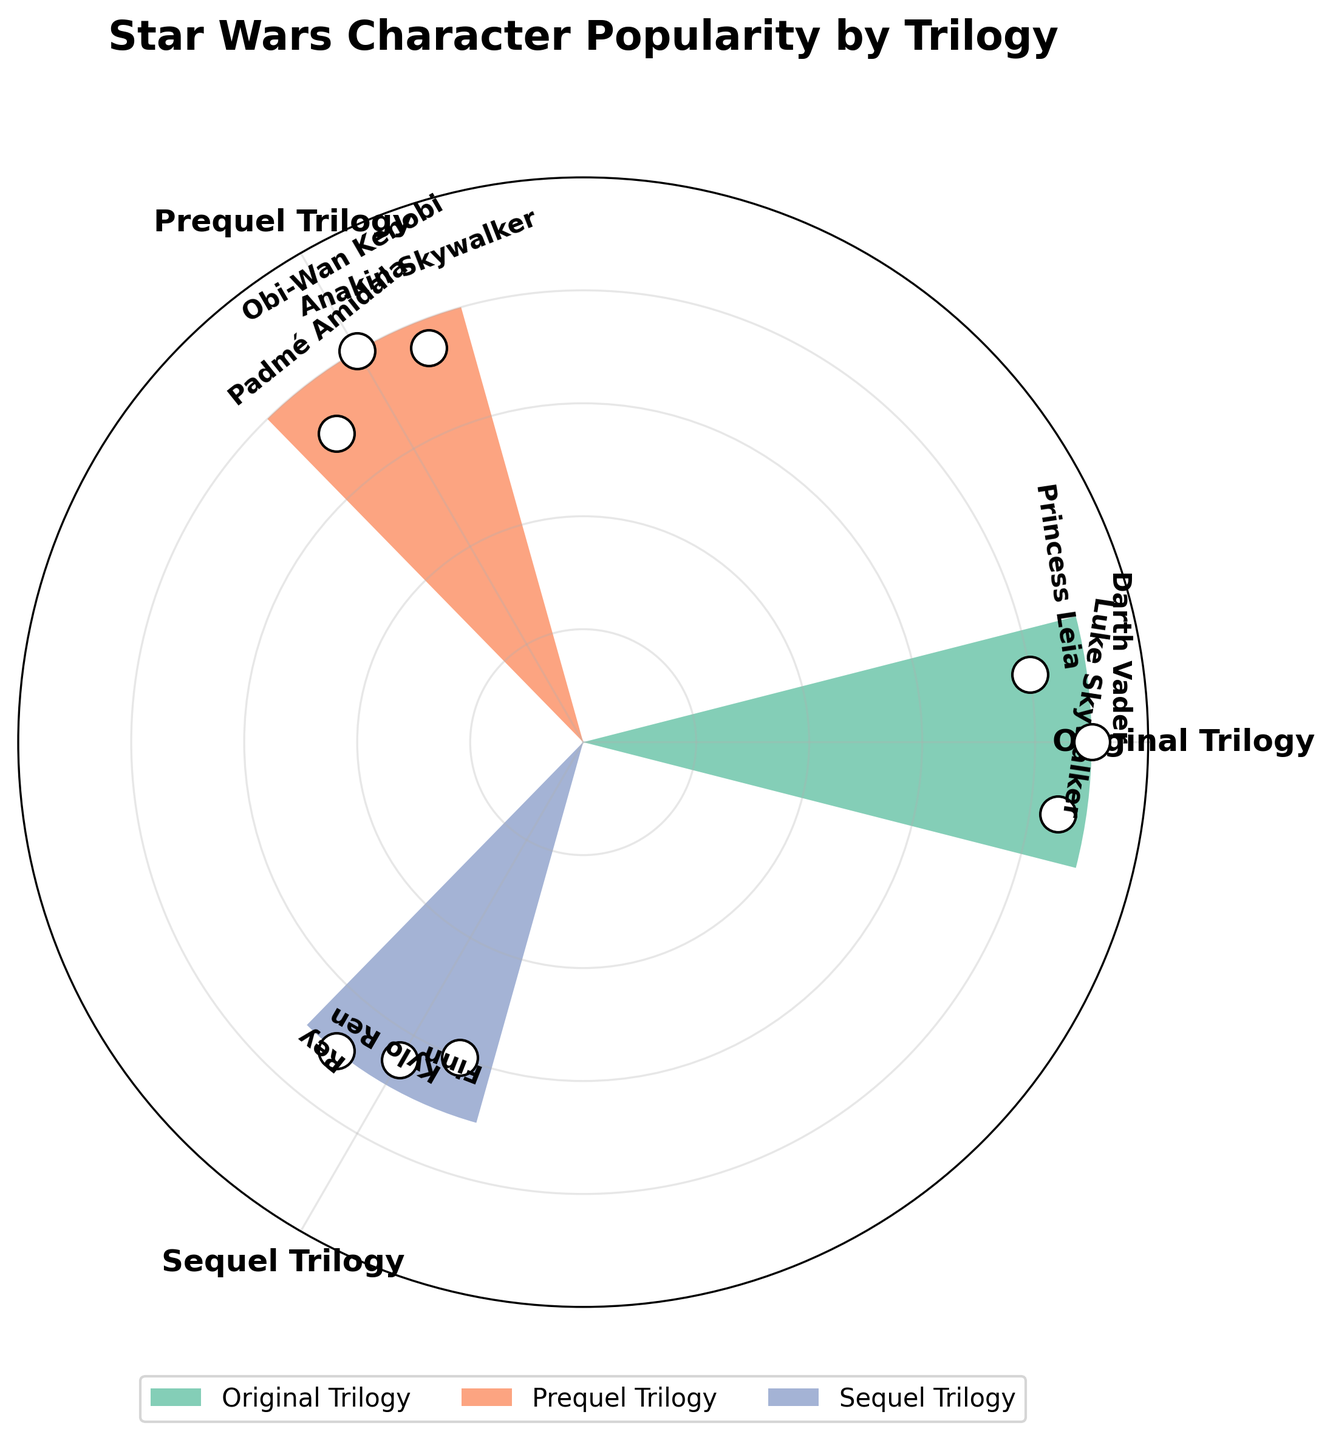what is the title of the figure? The title is usually placed at the top of the figure and is a textual description that captures the main topic or the purpose of the chart. Here, the title is "Star Wars Character Popularity by Trilogy" as seen at the top of the chart.
Answer: Star Wars Character Popularity by Trilogy How many trilogies are represented in the chart? The chart segments are arranged based on the trilogies, and there are three distinct segments shown here. Each segment represents one trilogy, as indicated by the unique colors and radial labels.
Answer: 3 What is the popularity score of Darth Vader from the Original Trilogy? For each character in each trilogy, there is a point and label. By looking at the Original Trilogy section, Darth Vader has a score marked at 90.
Answer: 90 Which character in the Sequel Trilogy has the lowest popularity score? The Sequel Trilogy section of the chart shows three characters. By comparing the data points and labels, Finn has the lowest score at 60.
Answer: Finn What is the difference in popularity between Anakin Skywalker and Kylo Ren? Anakin Skywalker from the Prequel Trilogy has a popularity score of 75, and Kylo Ren from the Sequel Trilogy has a popularity score of 65. The difference is calculated as 75 - 65 = 10.
Answer: 10 Which trilogy has the highest average popularity score based on its characters? To find the average, sum the popularity scores of each character in a trilogy and divide by the number of characters. Original Trilogy (85 + 90 + 80) / 3 = 85, Prequel Trilogy (75 + 80 + 70) / 3 = 75, Sequel Trilogy (70 + 65 + 60) / 3 = 65. The Original Trilogy has the highest average of 85.
Answer: Original Trilogy How many characters in total are there across all trilogies? Counting all the individual data points labeled for each trilogy, there are a total of three characters per trilogy multiplied by three trilogies, giving a total of 9 characters.
Answer: 9 Which character has the highest popularity score across all trilogies? By examining all the data points, Darth Vader from the Original Trilogy has the highest popularity score at 90 among all the characters displayed in different trilogies.
Answer: Darth Vader What is the median popularity score of all characters combined? Arrange all the popularity scores: 60, 65, 70, 70, 75, 80, 80, 85, 90. The middle value (median) in the sorted list is 75, which represents the median popularity score.
Answer: 75 Based on the chart, which trilogy has the widest range of popularity scores for its characters? The range is the difference between the highest and lowest scores within each trilogy. Original Trilogy: 90 - 80 = 10, Prequel Trilogy: 80 - 70 = 10, Sequel Trilogy: 70 - 60 = 10. All trilogies have a range of 10.
Answer: All trilogies 